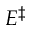Convert formula to latex. <formula><loc_0><loc_0><loc_500><loc_500>E ^ { \ddagger }</formula> 